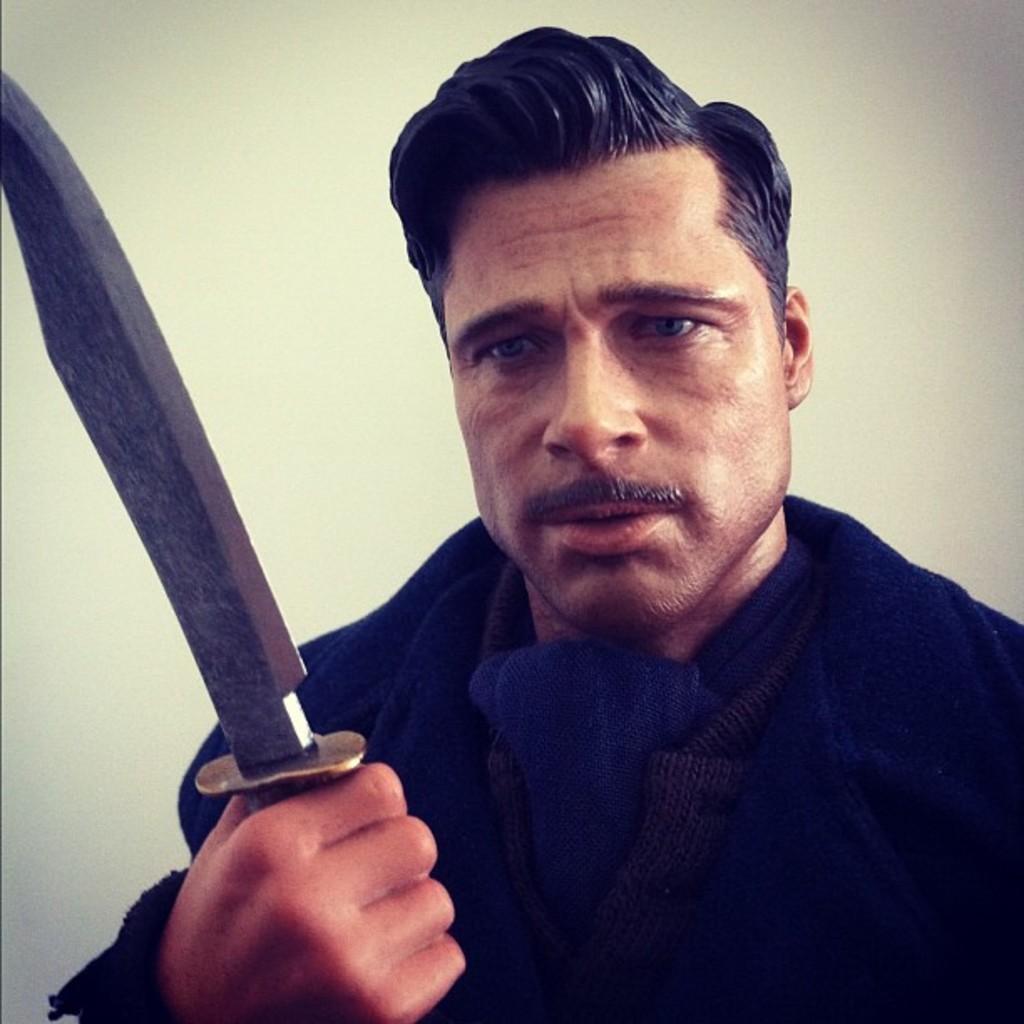What is the main subject of the picture? The main subject of the picture is an idol of a man. What is the man holding in the picture? The man is holding a knife. What type of yam is the man cooking in the image? There is no yam present in the image, and the man is not depicted as cooking anything. How many knots are tied on the man's clothing in the image? There are no knots present on the man's clothing in the image. 